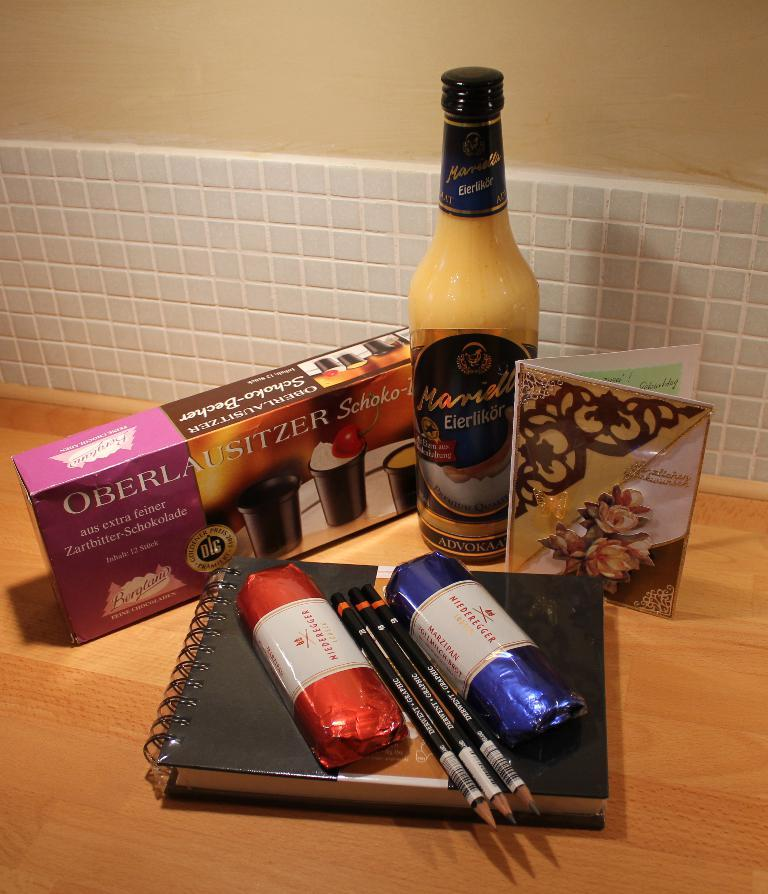<image>
Relay a brief, clear account of the picture shown. A box of Oberlausitzer sits on a wooden table with other items. 